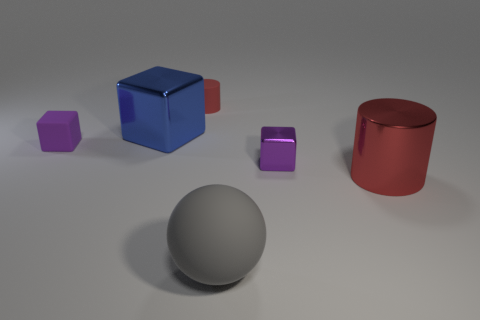How many purple matte blocks have the same size as the gray matte thing?
Provide a short and direct response. 0. What number of cyan objects are either small things or blocks?
Provide a short and direct response. 0. Are there the same number of big blue metal cubes to the left of the big shiny block and large yellow metal cylinders?
Ensure brevity in your answer.  Yes. What is the size of the red cylinder that is in front of the blue object?
Your answer should be compact. Large. How many metallic objects have the same shape as the purple rubber object?
Make the answer very short. 2. What is the large thing that is left of the big red cylinder and in front of the small purple rubber cube made of?
Offer a very short reply. Rubber. Are the big red cylinder and the large block made of the same material?
Offer a terse response. Yes. How many metal cylinders are there?
Make the answer very short. 1. What is the color of the big shiny thing that is to the left of the cylinder that is behind the large object on the right side of the gray sphere?
Your response must be concise. Blue. Is the small cylinder the same color as the big cylinder?
Your answer should be very brief. Yes. 